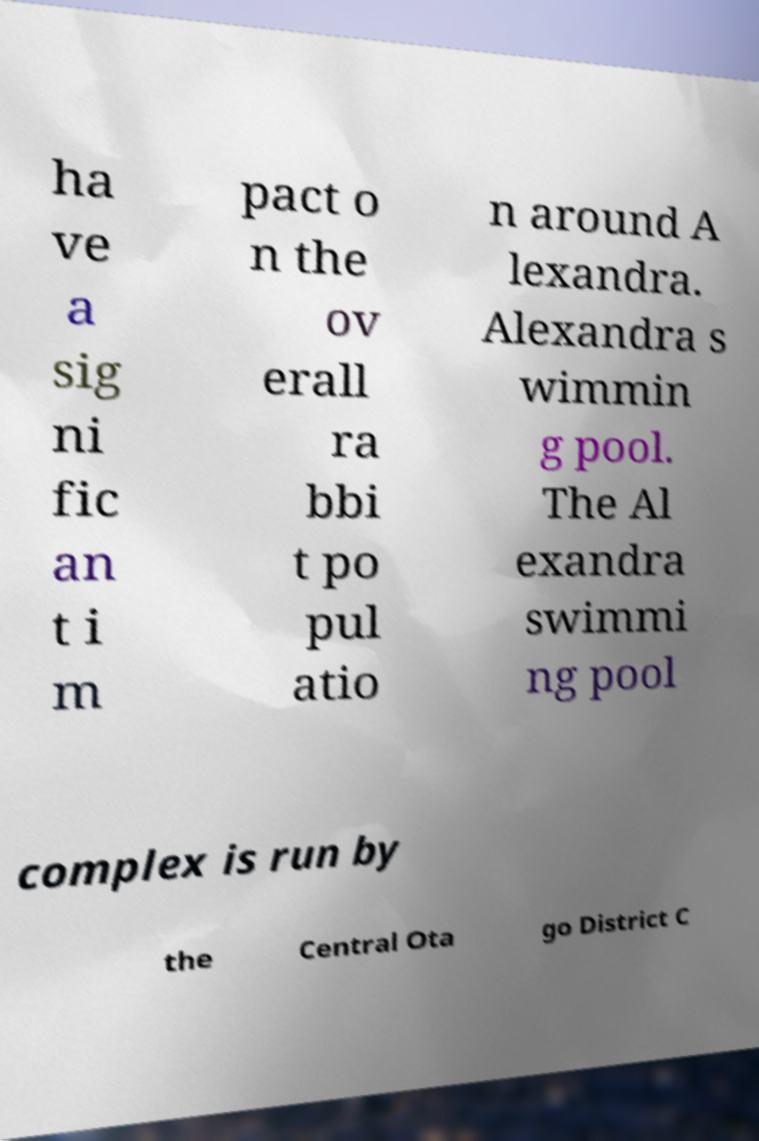What messages or text are displayed in this image? I need them in a readable, typed format. ha ve a sig ni fic an t i m pact o n the ov erall ra bbi t po pul atio n around A lexandra. Alexandra s wimmin g pool. The Al exandra swimmi ng pool complex is run by the Central Ota go District C 